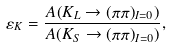Convert formula to latex. <formula><loc_0><loc_0><loc_500><loc_500>\varepsilon _ { K } = { \frac { { A ( K _ { L } \rightarrow ( \pi \pi ) _ { I = 0 } } ) } { A ( K _ { S } \rightarrow ( \pi \pi ) _ { I = 0 } ) } } ,</formula> 